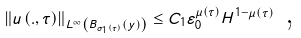Convert formula to latex. <formula><loc_0><loc_0><loc_500><loc_500>\left \| u \left ( . , \tau \right ) \right \| _ { L ^ { \infty } \left ( B _ { \sigma _ { 1 } \left ( \tau \right ) } \left ( y \right ) \right ) } \leq C _ { 1 } \varepsilon _ { 0 } ^ { \mu \left ( \tau \right ) } H ^ { 1 - \mu \left ( \tau \right ) } \text { ,}</formula> 